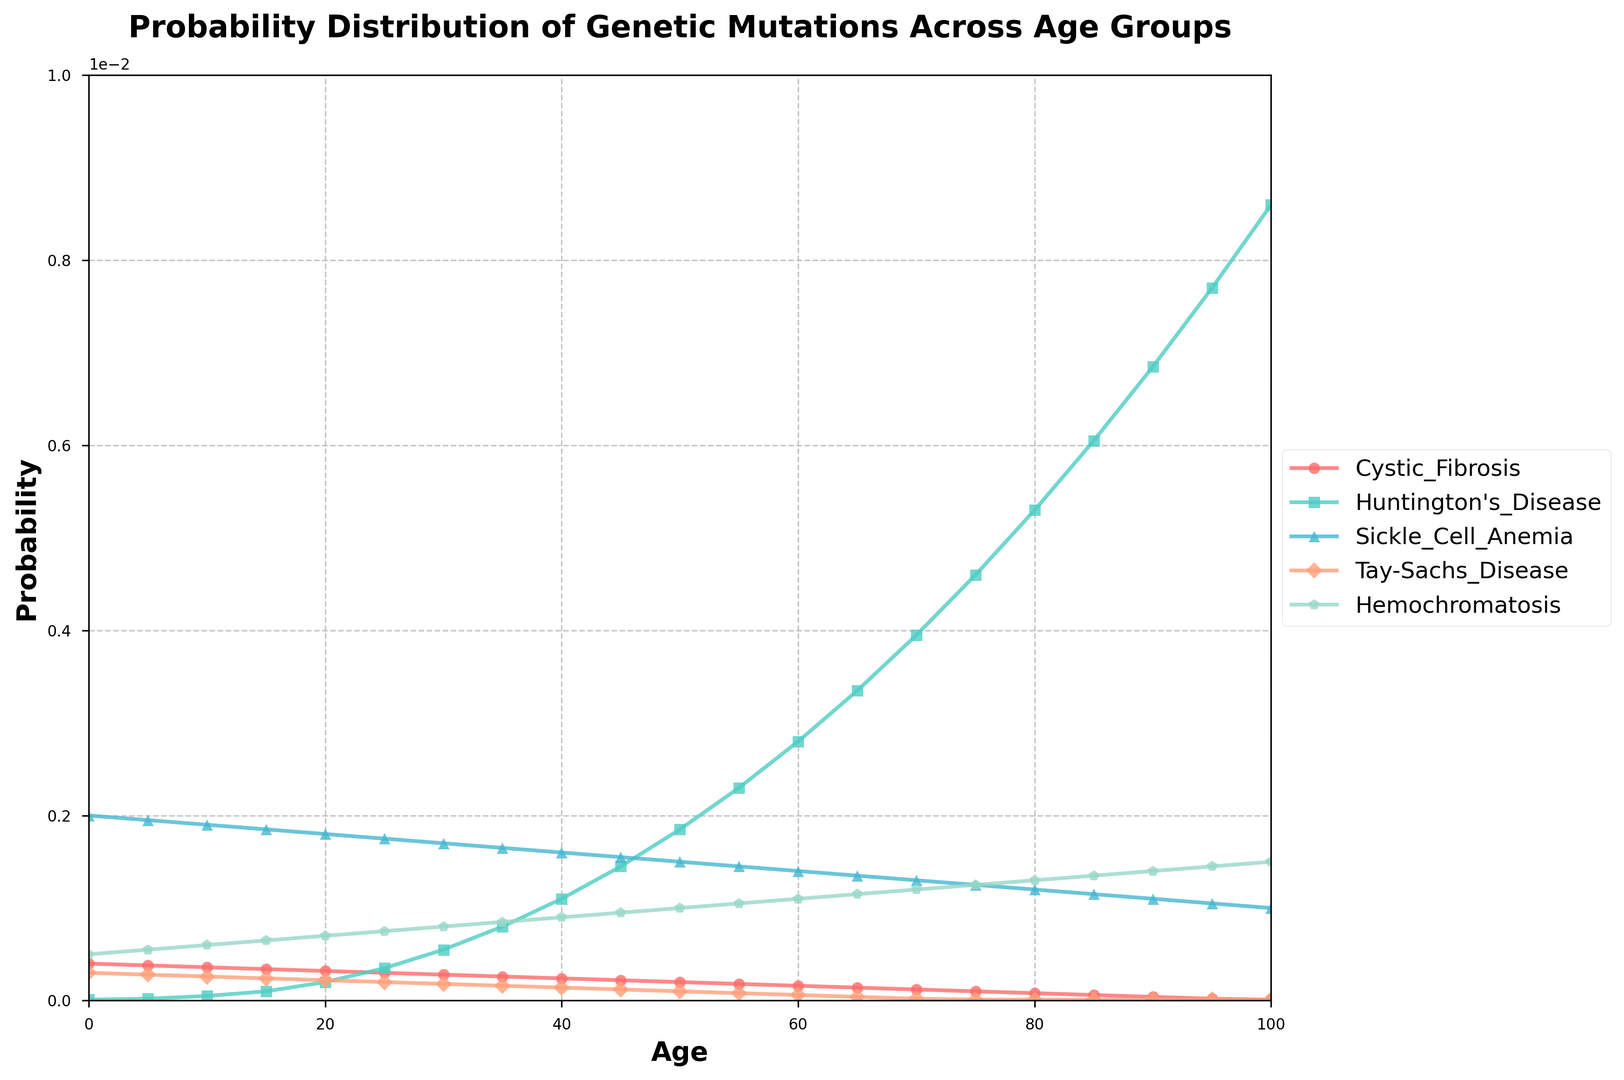What's the probability of Huntington's Disease at age 50? Find the point on the Huntington's Disease line where the age is 50 and read the corresponding probability from the y-axis.
Answer: 0.00185 Which disease has the lowest probability at age 10? Compare the vertical positions of the lines at age 10 and identify the one that is lowest.
Answer: Huntington's Disease How does the probability of Sickle Cell Anemia change from age 0 to age 25? Find the probabilities of Sickle Cell Anemia at ages 0 and 25 from the y-axis, then calculate the difference.
Answer: Decreases by 0.00025 (from 0.00200 to 0.00175) Which genetic mutation shows the largest increase in probability from age 0 to age 100? Determine the changes in probability for each disease from age 0 to age 100 and identify the largest change.
Answer: Huntington's Disease At age 60, what is the combined probability of Tay-Sachs Disease and Hemochromatosis? Read the probabilities of Tay-Sachs Disease and Hemochromatosis at age 60 and sum them up.
Answer: 0.00017 Is the probability of Hemochromatosis at age 80 greater than the probability of Cystic Fibrosis at age 80? Compare the heights of the points on the lines for Hemochromatosis and Cystic Fibrosis at age 80.
Answer: Yes (0.00130 vs. 0.00008) What can be observed about the trend in the probability of Cystic Fibrosis as age increases? Identify the direction (increasing or decreasing) of the Cystic Fibrosis line from left (age 0) to right (age 100).
Answer: Decreases By how much does the probability of Huntington's Disease exceed the probability of Tay-Sachs Disease at age 45? Subtract the probability of Tay-Sachs Disease from the probability of Huntington's Disease at age 45.
Answer: 0.00133 (0.00145 - 0.00012) Which genetic mutation has the flattest trend (least change) over the age groups? Observe each line and assess which has the least steepness or change from left to right.
Answer: Hemochromatosis How does the probability of each genetic mutation compare at age 100? List out the probabilities for each genetic mutation at age 100 and compare them.
Answer: Hemochromatosis > Huntington's Disease > Sickle Cell Anemia > Cystic Fibrosis = Tay-Sachs Disease 